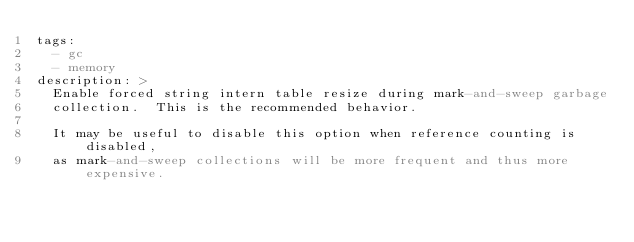Convert code to text. <code><loc_0><loc_0><loc_500><loc_500><_YAML_>tags:
  - gc
  - memory
description: >
  Enable forced string intern table resize during mark-and-sweep garbage
  collection.  This is the recommended behavior.

  It may be useful to disable this option when reference counting is disabled,
  as mark-and-sweep collections will be more frequent and thus more expensive.
</code> 